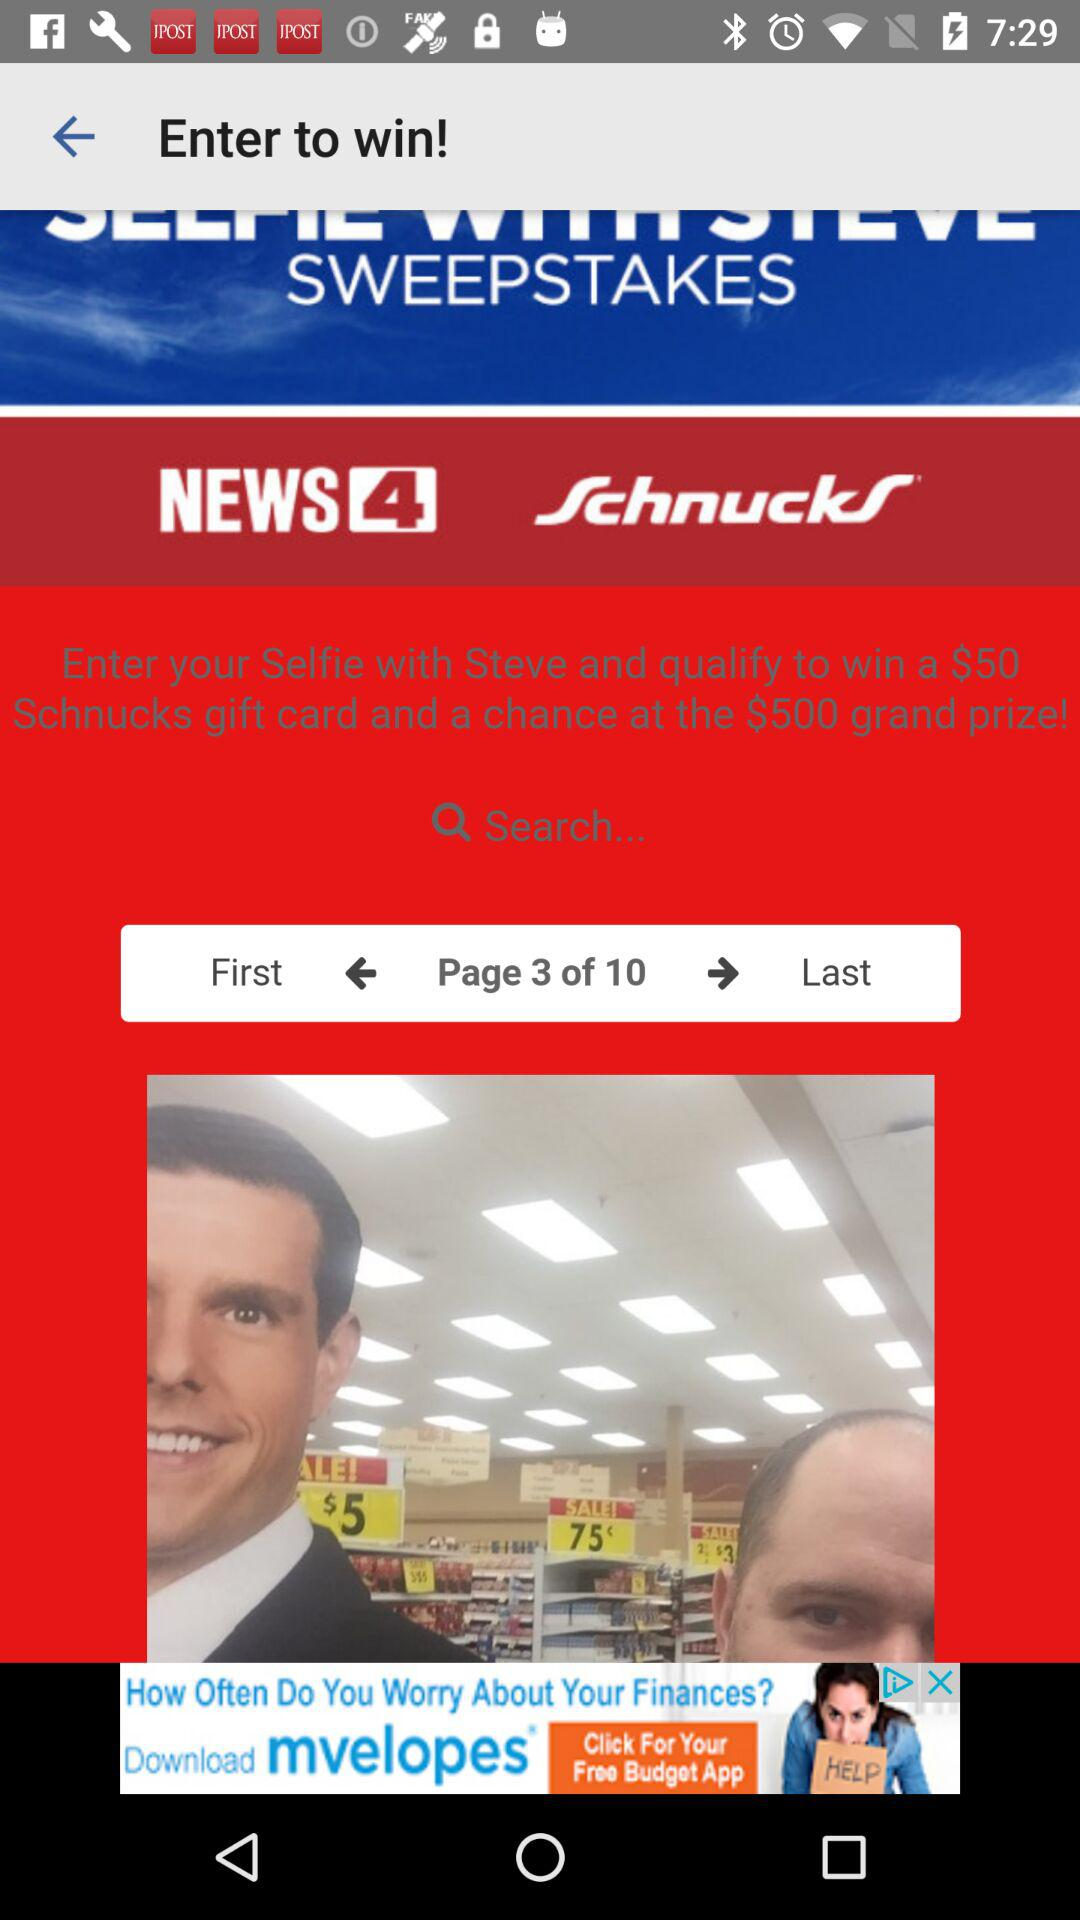How many dollars is the grand prize?
Answer the question using a single word or phrase. $500 